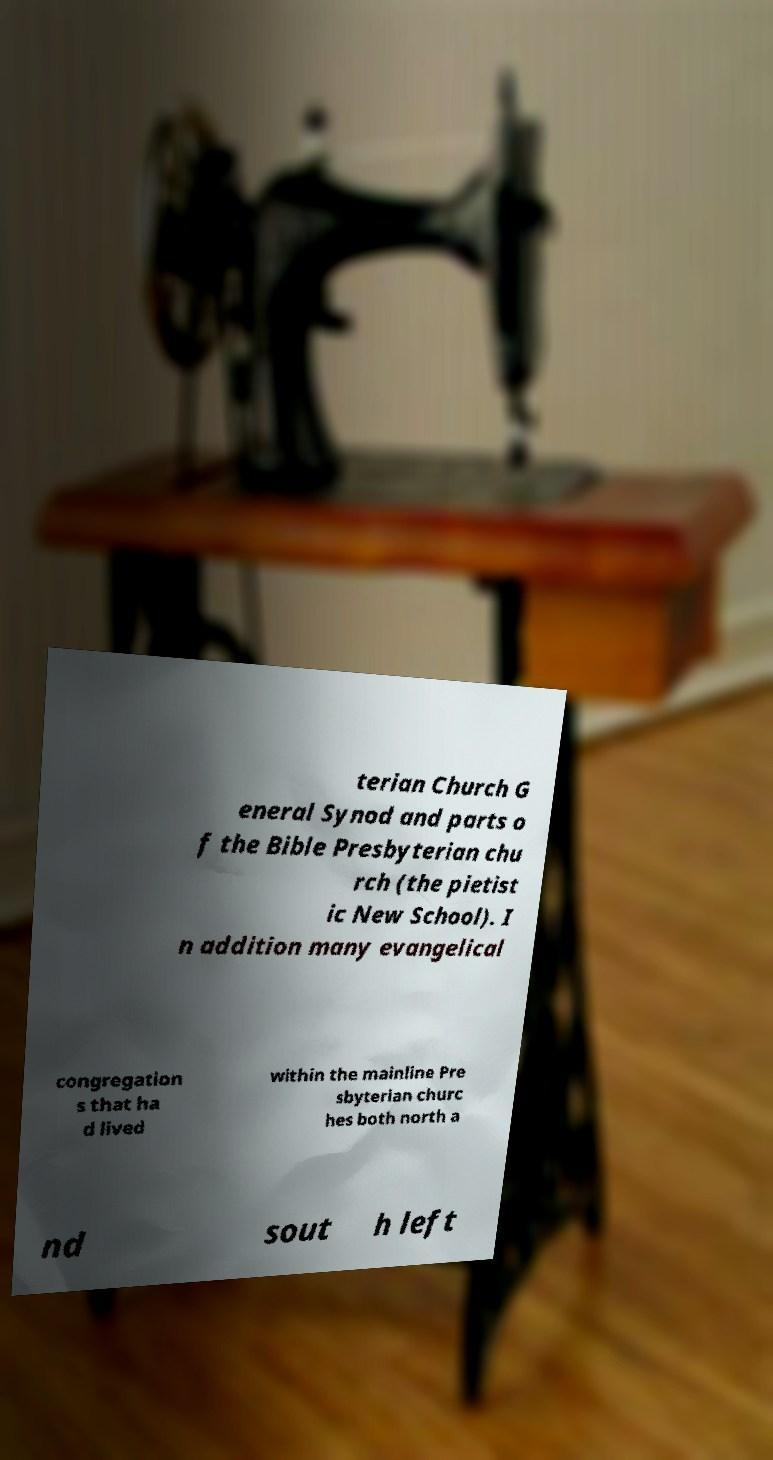Can you read and provide the text displayed in the image?This photo seems to have some interesting text. Can you extract and type it out for me? terian Church G eneral Synod and parts o f the Bible Presbyterian chu rch (the pietist ic New School). I n addition many evangelical congregation s that ha d lived within the mainline Pre sbyterian churc hes both north a nd sout h left 